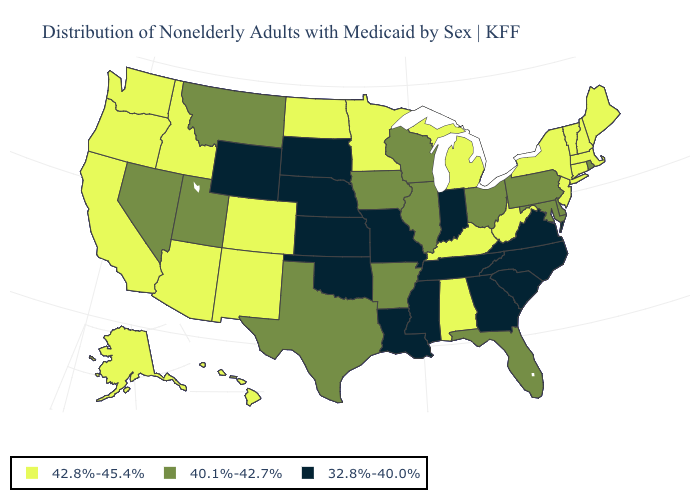What is the value of Washington?
Concise answer only. 42.8%-45.4%. What is the value of Vermont?
Concise answer only. 42.8%-45.4%. Does Vermont have the lowest value in the USA?
Write a very short answer. No. Which states have the lowest value in the Northeast?
Concise answer only. Pennsylvania, Rhode Island. Name the states that have a value in the range 40.1%-42.7%?
Be succinct. Arkansas, Delaware, Florida, Illinois, Iowa, Maryland, Montana, Nevada, Ohio, Pennsylvania, Rhode Island, Texas, Utah, Wisconsin. What is the highest value in states that border Vermont?
Short answer required. 42.8%-45.4%. How many symbols are there in the legend?
Write a very short answer. 3. How many symbols are there in the legend?
Short answer required. 3. What is the lowest value in states that border Tennessee?
Be succinct. 32.8%-40.0%. Name the states that have a value in the range 32.8%-40.0%?
Keep it brief. Georgia, Indiana, Kansas, Louisiana, Mississippi, Missouri, Nebraska, North Carolina, Oklahoma, South Carolina, South Dakota, Tennessee, Virginia, Wyoming. What is the lowest value in the USA?
Quick response, please. 32.8%-40.0%. Name the states that have a value in the range 42.8%-45.4%?
Answer briefly. Alabama, Alaska, Arizona, California, Colorado, Connecticut, Hawaii, Idaho, Kentucky, Maine, Massachusetts, Michigan, Minnesota, New Hampshire, New Jersey, New Mexico, New York, North Dakota, Oregon, Vermont, Washington, West Virginia. Does the first symbol in the legend represent the smallest category?
Answer briefly. No. Does Oregon have the lowest value in the USA?
Give a very brief answer. No. What is the value of Alabama?
Give a very brief answer. 42.8%-45.4%. 